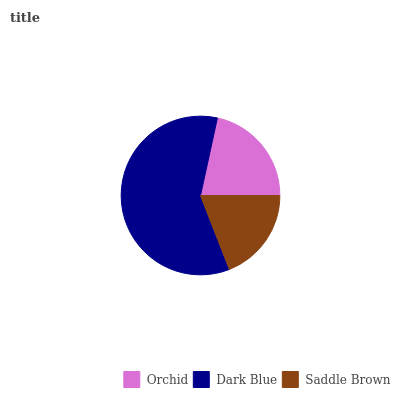Is Saddle Brown the minimum?
Answer yes or no. Yes. Is Dark Blue the maximum?
Answer yes or no. Yes. Is Dark Blue the minimum?
Answer yes or no. No. Is Saddle Brown the maximum?
Answer yes or no. No. Is Dark Blue greater than Saddle Brown?
Answer yes or no. Yes. Is Saddle Brown less than Dark Blue?
Answer yes or no. Yes. Is Saddle Brown greater than Dark Blue?
Answer yes or no. No. Is Dark Blue less than Saddle Brown?
Answer yes or no. No. Is Orchid the high median?
Answer yes or no. Yes. Is Orchid the low median?
Answer yes or no. Yes. Is Dark Blue the high median?
Answer yes or no. No. Is Dark Blue the low median?
Answer yes or no. No. 